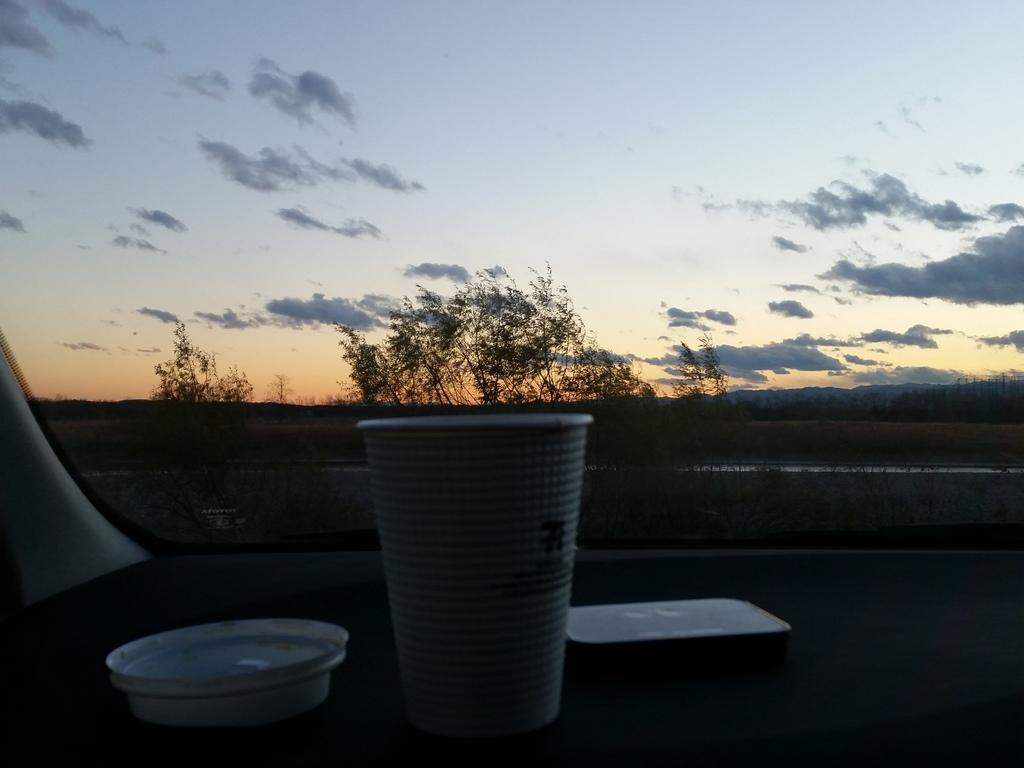What is present in the image that can hold a liquid? There is a cup in the image. Is there anything covering the cup in the image? Yes, there is a lid in the image. What can be seen on the surface in the image? There are objects on the surface in the image. What type of natural scenery is visible in the background of the image? There are trees visible in the background of the image. What is the color of the sky in the image? The sky is blue and white in color. What type of note can be seen hanging from the trees in the image? There are no notes hanging from the trees in the image; only trees are visible in the background. What scent can be detected from the objects on the surface in the image? There is no information about the scent of the objects in the image, as we are only given visual information. 